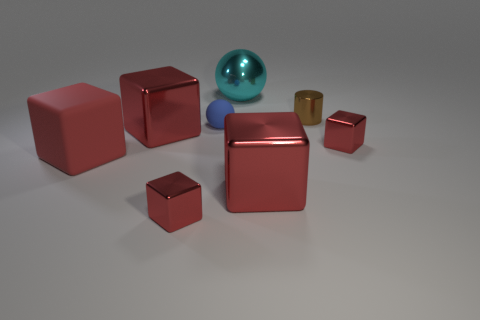Subtract all red cubes. How many were subtracted if there are1red cubes left? 4 Subtract all metallic cubes. How many cubes are left? 1 Subtract 2 cubes. How many cubes are left? 3 Add 2 tiny yellow metallic objects. How many objects exist? 10 Subtract all purple blocks. Subtract all purple cylinders. How many blocks are left? 5 Subtract all cylinders. How many objects are left? 7 Add 4 large metal balls. How many large metal balls are left? 5 Add 4 small metal cylinders. How many small metal cylinders exist? 5 Subtract 0 cyan cylinders. How many objects are left? 8 Subtract all blue matte things. Subtract all brown things. How many objects are left? 6 